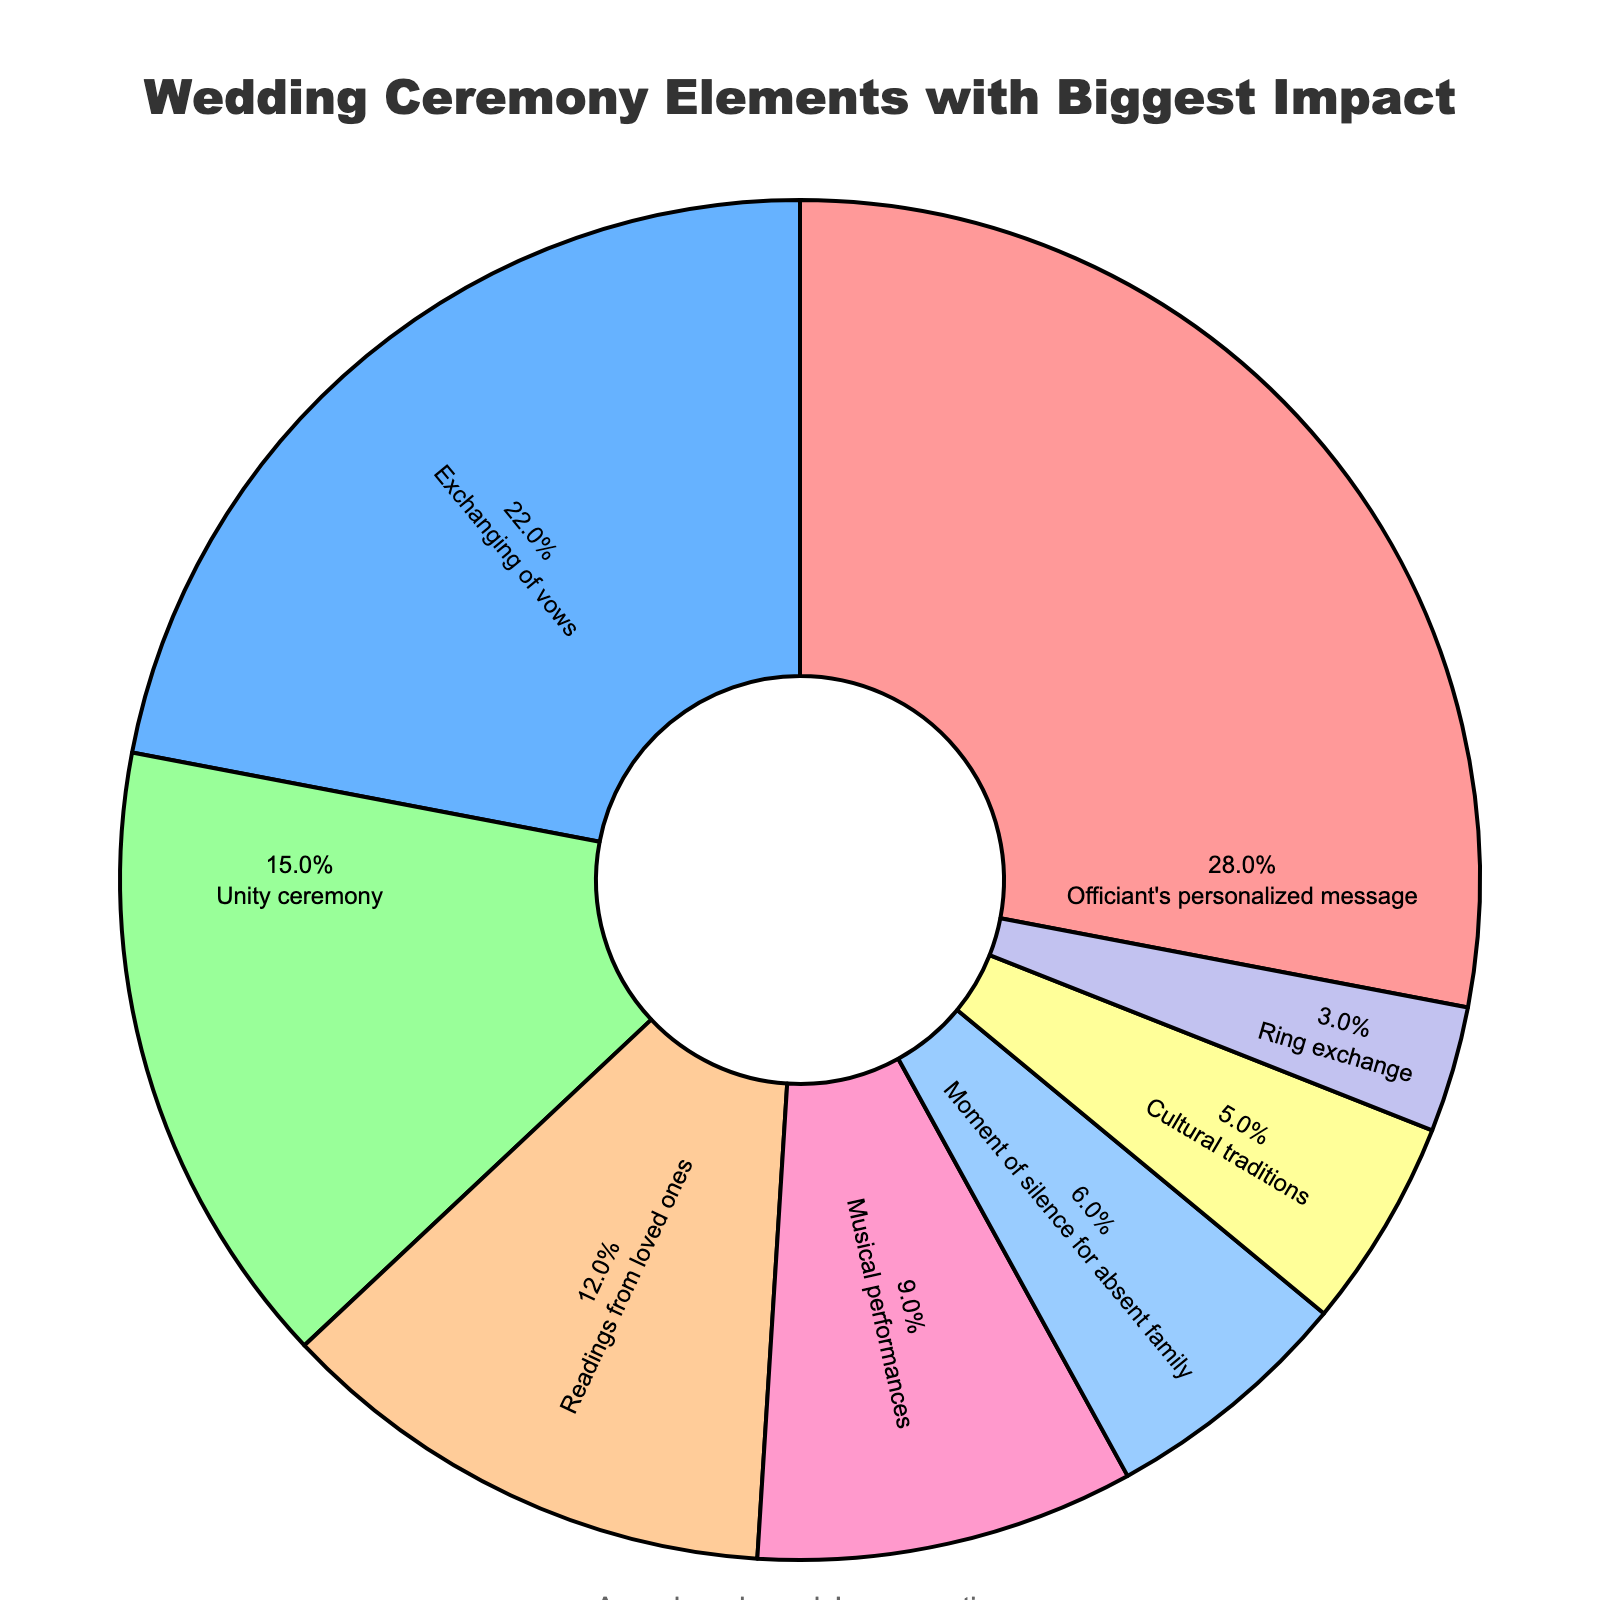What element has the highest impact percentage in the pie chart? The element with the highest impact percentage can be identified by looking for the largest segment in the pie chart. This segment represents the "Officiant's personalized message" at 28%.
Answer: Officiant's personalized message What is the combined percentage of the "Unity ceremony" and "Moment of silence for absent family"? To find the combined percentage of these two elements, add their individual percentages: 15% (Unity ceremony) + 6% (Moment of silence for absent family) = 21%.
Answer: 21% Which element has a lower impact, "Ring exchange" or "Cultural traditions"? To determine which element has a lower impact, compare their percentages. The "Ring exchange" has 3%, and "Cultural traditions" has 5%. Thus, "Ring exchange" has a lower impact.
Answer: Ring exchange What is the difference in impact percentage between the "Exchanging of vows" and the "Musical performances"? The difference can be calculated by subtracting the smaller percentage from the larger one: 22% (Exchanging of vows) - 9% (Musical performances) = 13%.
Answer: 13% If you combine the impact percentages of "Readings from loved ones" and "Musical performances," does their total impact exceed that of the "Exchanging of vows"? Add the percentages of "Readings from loved ones" (12%) and "Musical performances" (9%): 12% + 9% = 21%. Compare this with the "Exchanging of vows" at 22%. Since 21% < 22%, their combined impact does not exceed "Exchanging of vows".
Answer: No What is the percentage difference between the element with the highest impact and the element with the lowest impact? Subtract the percentage of the element with the lowest impact ("Ring exchange" at 3%) from the highest impact ("Officiant's personalized message" at 28%): 28% - 3% = 25%.
Answer: 25% Which element is represented by the green segment in the pie chart? To determine this, find the specific color tied to an element in the chart. In this case, the "Unity ceremony" uses the green segment.
Answer: Unity ceremony If we group "Officiant's personalized message" and "Exchanging of vows" together, what fraction of the entire impact do they represent? First, add the percentages of the two elements: 28% (Officiant's personalized message) + 22% (Exchanging of vows) = 50%. Hence, they represent 50% of the total.
Answer: 50% How do the impact percentages of "Musical performances" and "Moment of silence for absent family" compare? Compare the two percentages directly: "Musical performances" have 9% and "Moment of silence for absent family" has 6%. Therefore, "Musical performances" have a higher impact percentage.
Answer: Musical performances have a higher impact percentage Which two elements contribute equally to the total impact percentage? Look for elements with the same percentages. Both "Unity ceremony" and "Readings from loved ones" each contribute 12% to the total impact.
Answer: Unity ceremony and Readings from loved ones 